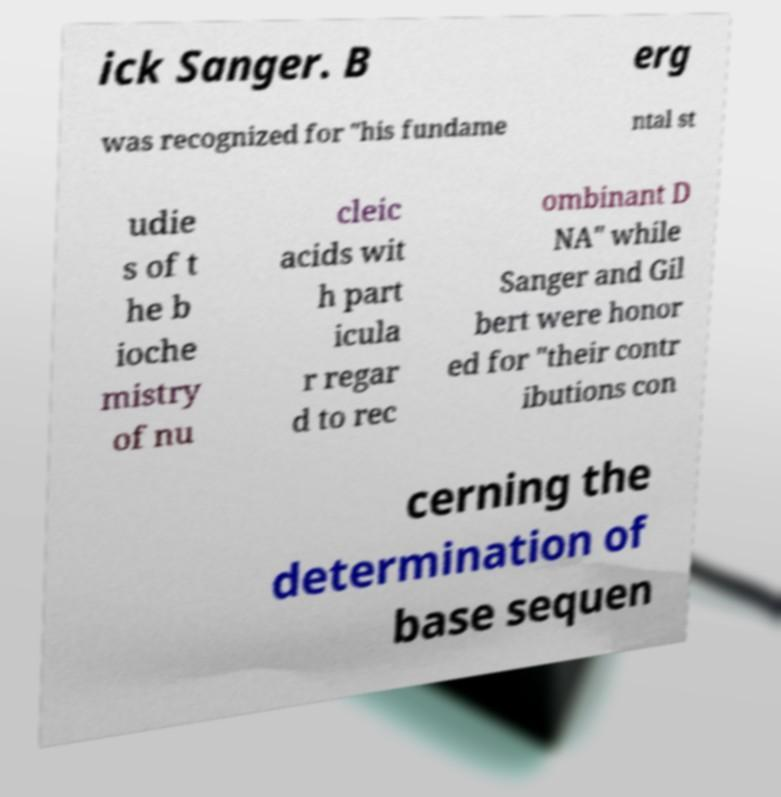Could you extract and type out the text from this image? ick Sanger. B erg was recognized for "his fundame ntal st udie s of t he b ioche mistry of nu cleic acids wit h part icula r regar d to rec ombinant D NA" while Sanger and Gil bert were honor ed for "their contr ibutions con cerning the determination of base sequen 